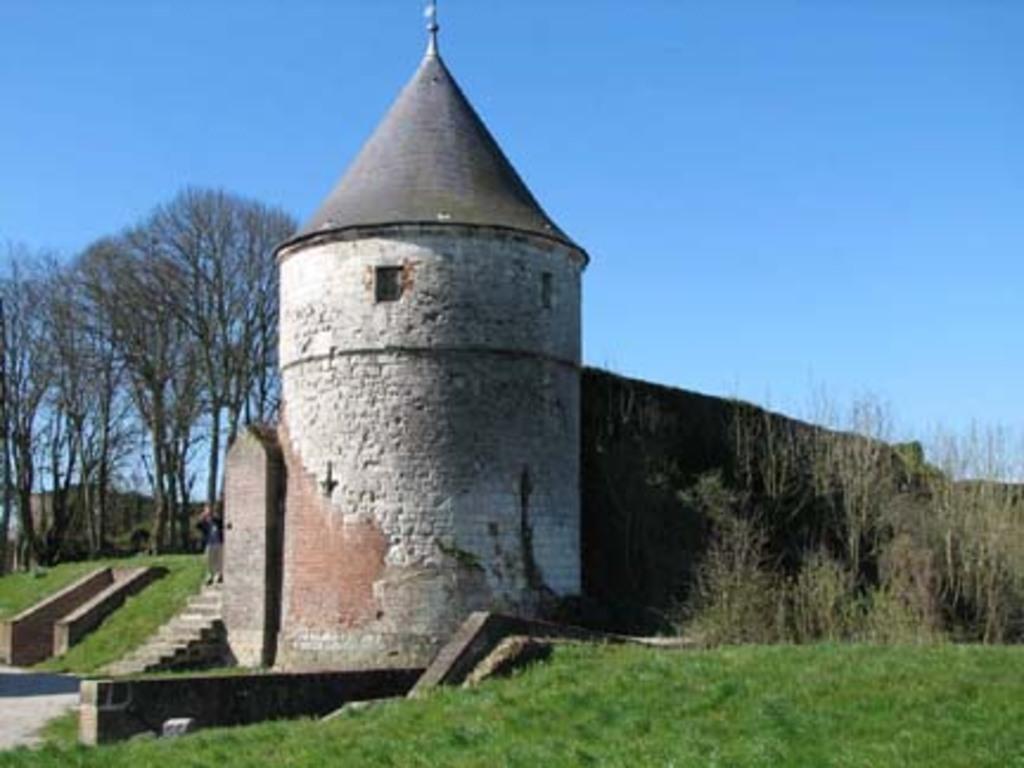Can you describe this image briefly? In the center of a picture there is a wall and castle like construction. On the right there are trees. On the left there are trees and wall. In the foreground there is grass. In the center of the picture there is a staircase, on the staircase there is a person. In the background it is sky. 